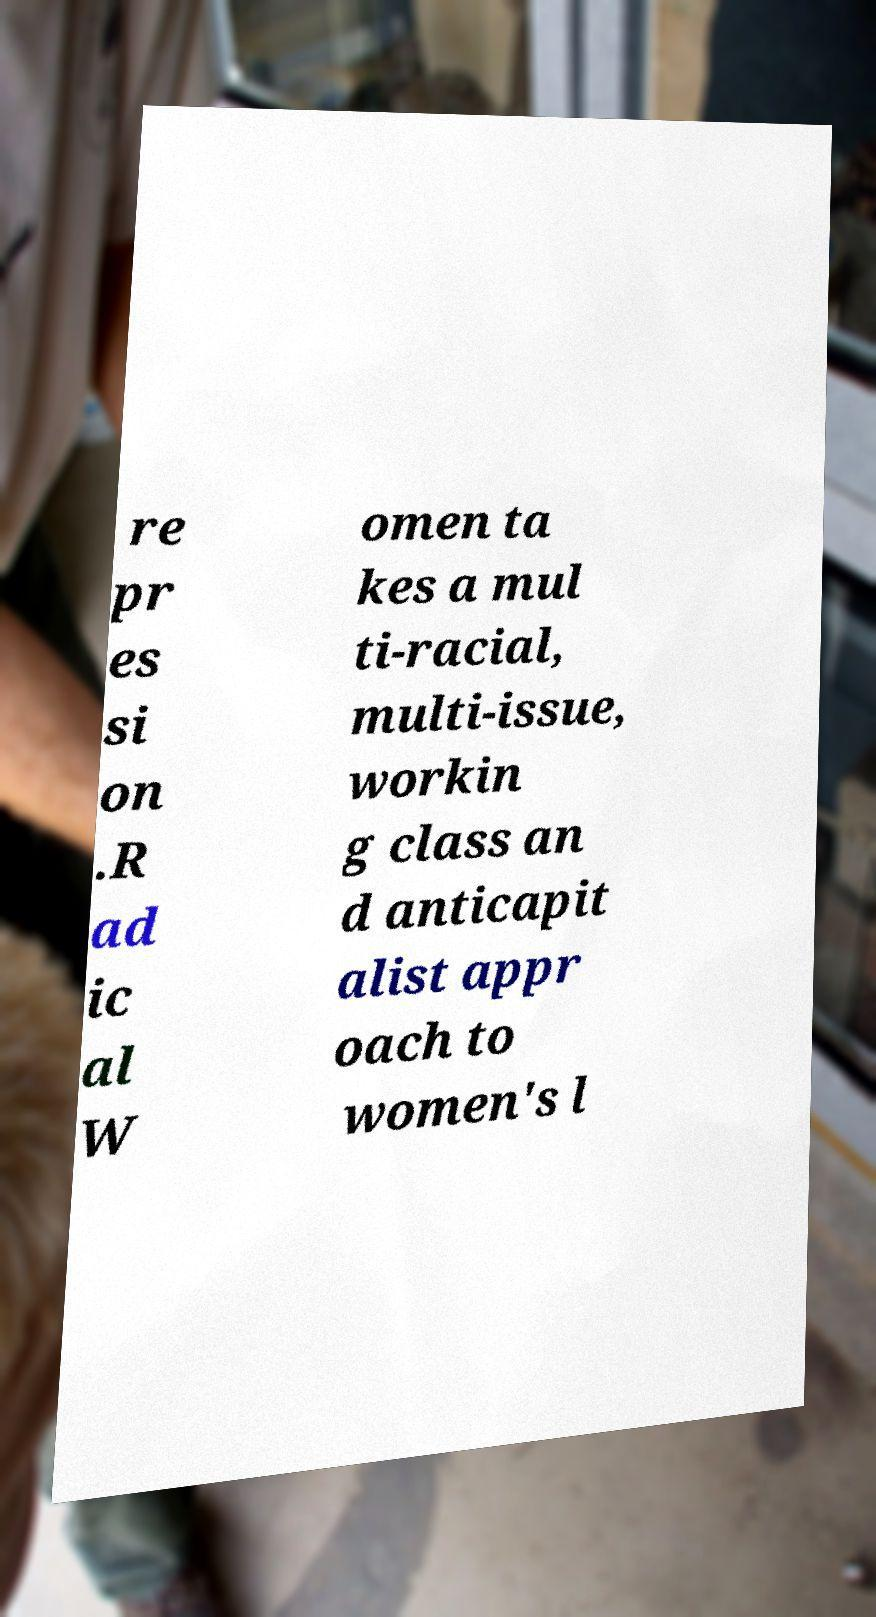Please identify and transcribe the text found in this image. re pr es si on .R ad ic al W omen ta kes a mul ti-racial, multi-issue, workin g class an d anticapit alist appr oach to women's l 